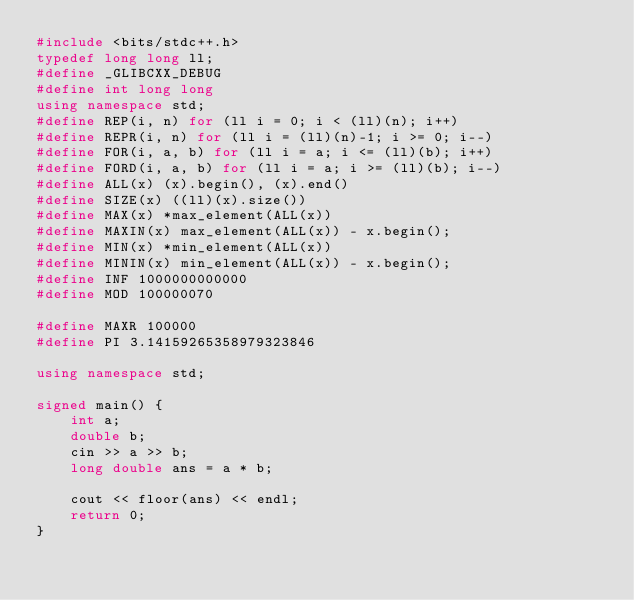Convert code to text. <code><loc_0><loc_0><loc_500><loc_500><_C++_>#include <bits/stdc++.h>
typedef long long ll;
#define _GLIBCXX_DEBUG
#define int long long
using namespace std;
#define REP(i, n) for (ll i = 0; i < (ll)(n); i++)
#define REPR(i, n) for (ll i = (ll)(n)-1; i >= 0; i--)
#define FOR(i, a, b) for (ll i = a; i <= (ll)(b); i++)
#define FORD(i, a, b) for (ll i = a; i >= (ll)(b); i--)
#define ALL(x) (x).begin(), (x).end()
#define SIZE(x) ((ll)(x).size())
#define MAX(x) *max_element(ALL(x))
#define MAXIN(x) max_element(ALL(x)) - x.begin();
#define MIN(x) *min_element(ALL(x))
#define MININ(x) min_element(ALL(x)) - x.begin();
#define INF 1000000000000
#define MOD 100000070

#define MAXR 100000
#define PI 3.14159265358979323846

using namespace std;

signed main() {
    int a;
    double b;
    cin >> a >> b;
    long double ans = a * b;

    cout << floor(ans) << endl;
    return 0;
}</code> 